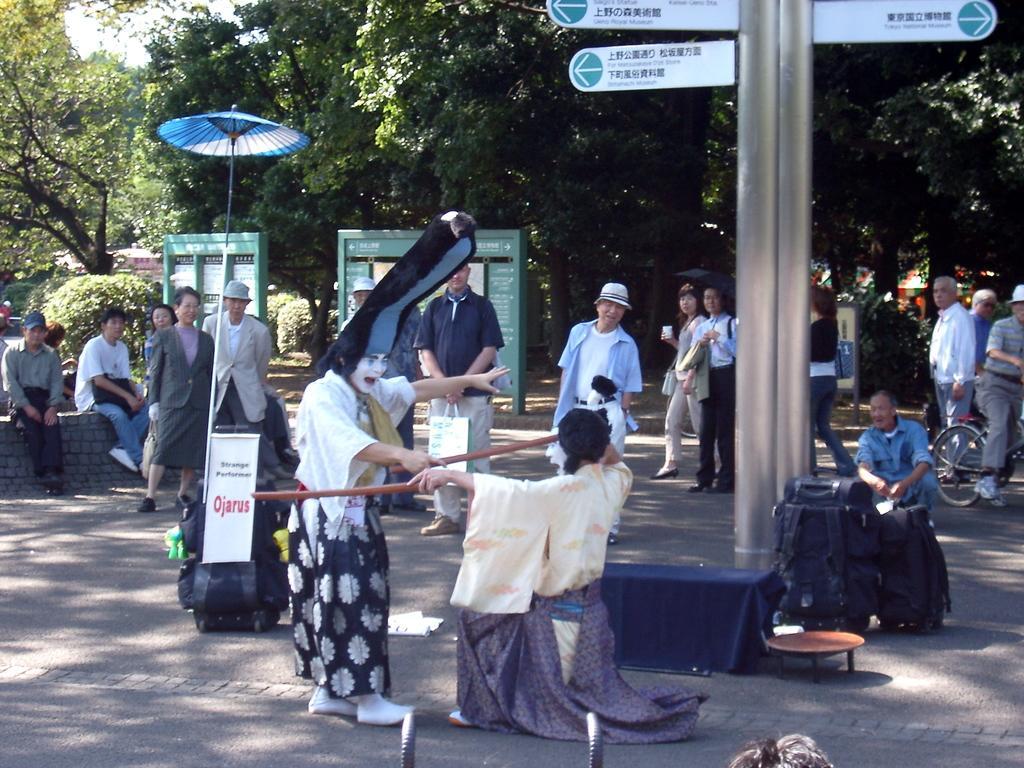Describe this image in one or two sentences. In this image we can see poles, sign board, bags, wooden table and an umbrella. We can see men and women are standing on the road and watching a show. In the background, tree are there. 